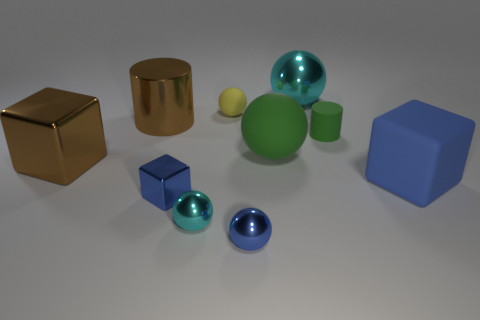Subtract all tiny cyan metal spheres. How many spheres are left? 4 Subtract all purple balls. How many blue cubes are left? 2 Subtract all yellow balls. How many balls are left? 4 Subtract all blocks. How many objects are left? 7 Subtract all tiny yellow rubber cylinders. Subtract all blue rubber things. How many objects are left? 9 Add 8 small blue shiny blocks. How many small blue shiny blocks are left? 9 Add 9 yellow metallic spheres. How many yellow metallic spheres exist? 9 Subtract 2 blue blocks. How many objects are left? 8 Subtract all brown blocks. Subtract all gray cylinders. How many blocks are left? 2 